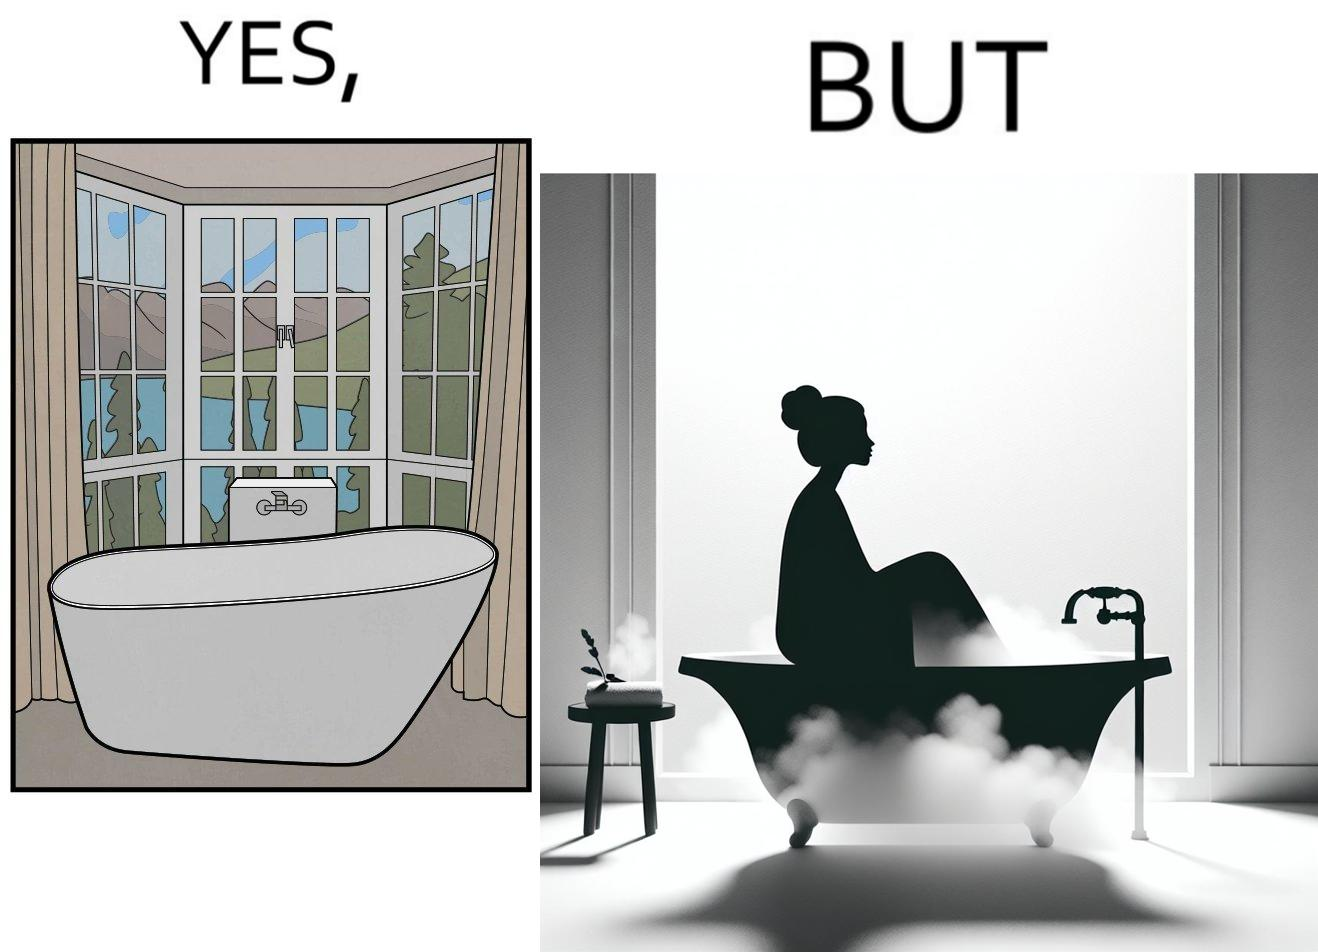Does this image contain satire or humor? Yes, this image is satirical. 